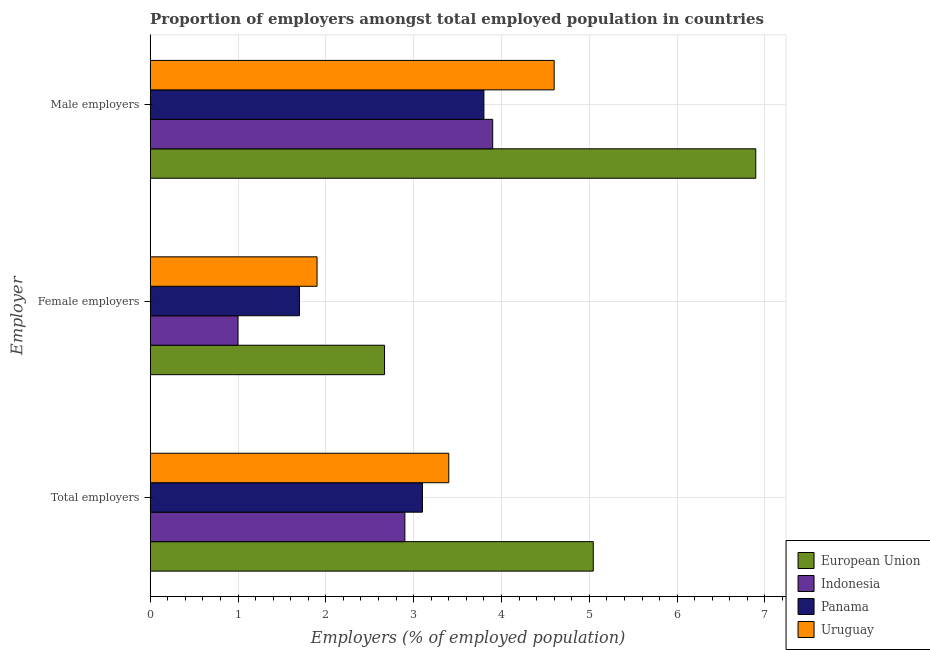How many different coloured bars are there?
Your answer should be compact. 4. Are the number of bars per tick equal to the number of legend labels?
Make the answer very short. Yes. Are the number of bars on each tick of the Y-axis equal?
Offer a very short reply. Yes. How many bars are there on the 2nd tick from the bottom?
Provide a short and direct response. 4. What is the label of the 2nd group of bars from the top?
Offer a very short reply. Female employers. What is the percentage of male employers in Uruguay?
Give a very brief answer. 4.6. Across all countries, what is the maximum percentage of total employers?
Offer a terse response. 5.05. Across all countries, what is the minimum percentage of total employers?
Provide a succinct answer. 2.9. In which country was the percentage of male employers minimum?
Your response must be concise. Panama. What is the total percentage of female employers in the graph?
Keep it short and to the point. 7.27. What is the difference between the percentage of male employers in Panama and that in Indonesia?
Give a very brief answer. -0.1. What is the difference between the percentage of female employers in Uruguay and the percentage of total employers in European Union?
Ensure brevity in your answer.  -3.15. What is the average percentage of female employers per country?
Your answer should be compact. 1.82. What is the difference between the percentage of female employers and percentage of male employers in European Union?
Your answer should be very brief. -4.23. In how many countries, is the percentage of female employers greater than 3.6 %?
Keep it short and to the point. 0. What is the ratio of the percentage of total employers in Panama to that in Indonesia?
Your answer should be very brief. 1.07. Is the percentage of male employers in Indonesia less than that in Uruguay?
Provide a short and direct response. Yes. What is the difference between the highest and the second highest percentage of male employers?
Offer a very short reply. 2.3. What is the difference between the highest and the lowest percentage of male employers?
Make the answer very short. 3.1. Is the sum of the percentage of total employers in Indonesia and European Union greater than the maximum percentage of male employers across all countries?
Provide a short and direct response. Yes. What does the 1st bar from the top in Male employers represents?
Make the answer very short. Uruguay. What does the 4th bar from the bottom in Male employers represents?
Your answer should be compact. Uruguay. How many countries are there in the graph?
Keep it short and to the point. 4. Does the graph contain any zero values?
Give a very brief answer. No. Does the graph contain grids?
Your answer should be compact. Yes. Where does the legend appear in the graph?
Your answer should be compact. Bottom right. How are the legend labels stacked?
Give a very brief answer. Vertical. What is the title of the graph?
Your response must be concise. Proportion of employers amongst total employed population in countries. Does "Papua New Guinea" appear as one of the legend labels in the graph?
Offer a terse response. No. What is the label or title of the X-axis?
Your answer should be very brief. Employers (% of employed population). What is the label or title of the Y-axis?
Give a very brief answer. Employer. What is the Employers (% of employed population) of European Union in Total employers?
Give a very brief answer. 5.05. What is the Employers (% of employed population) of Indonesia in Total employers?
Offer a very short reply. 2.9. What is the Employers (% of employed population) of Panama in Total employers?
Give a very brief answer. 3.1. What is the Employers (% of employed population) in Uruguay in Total employers?
Provide a succinct answer. 3.4. What is the Employers (% of employed population) of European Union in Female employers?
Your answer should be compact. 2.67. What is the Employers (% of employed population) of Indonesia in Female employers?
Keep it short and to the point. 1. What is the Employers (% of employed population) in Panama in Female employers?
Your answer should be very brief. 1.7. What is the Employers (% of employed population) in Uruguay in Female employers?
Keep it short and to the point. 1.9. What is the Employers (% of employed population) of European Union in Male employers?
Provide a short and direct response. 6.9. What is the Employers (% of employed population) of Indonesia in Male employers?
Your response must be concise. 3.9. What is the Employers (% of employed population) of Panama in Male employers?
Your response must be concise. 3.8. What is the Employers (% of employed population) of Uruguay in Male employers?
Ensure brevity in your answer.  4.6. Across all Employer, what is the maximum Employers (% of employed population) of European Union?
Provide a succinct answer. 6.9. Across all Employer, what is the maximum Employers (% of employed population) of Indonesia?
Keep it short and to the point. 3.9. Across all Employer, what is the maximum Employers (% of employed population) in Panama?
Offer a very short reply. 3.8. Across all Employer, what is the maximum Employers (% of employed population) in Uruguay?
Provide a short and direct response. 4.6. Across all Employer, what is the minimum Employers (% of employed population) in European Union?
Keep it short and to the point. 2.67. Across all Employer, what is the minimum Employers (% of employed population) of Panama?
Offer a terse response. 1.7. Across all Employer, what is the minimum Employers (% of employed population) in Uruguay?
Your response must be concise. 1.9. What is the total Employers (% of employed population) in European Union in the graph?
Give a very brief answer. 14.61. What is the total Employers (% of employed population) in Indonesia in the graph?
Give a very brief answer. 7.8. What is the total Employers (% of employed population) in Panama in the graph?
Your answer should be compact. 8.6. What is the difference between the Employers (% of employed population) of European Union in Total employers and that in Female employers?
Offer a very short reply. 2.38. What is the difference between the Employers (% of employed population) in Indonesia in Total employers and that in Female employers?
Your response must be concise. 1.9. What is the difference between the Employers (% of employed population) of European Union in Total employers and that in Male employers?
Offer a terse response. -1.85. What is the difference between the Employers (% of employed population) in Uruguay in Total employers and that in Male employers?
Keep it short and to the point. -1.2. What is the difference between the Employers (% of employed population) of European Union in Female employers and that in Male employers?
Provide a short and direct response. -4.23. What is the difference between the Employers (% of employed population) in Indonesia in Female employers and that in Male employers?
Keep it short and to the point. -2.9. What is the difference between the Employers (% of employed population) in European Union in Total employers and the Employers (% of employed population) in Indonesia in Female employers?
Provide a succinct answer. 4.05. What is the difference between the Employers (% of employed population) of European Union in Total employers and the Employers (% of employed population) of Panama in Female employers?
Give a very brief answer. 3.35. What is the difference between the Employers (% of employed population) in European Union in Total employers and the Employers (% of employed population) in Uruguay in Female employers?
Offer a terse response. 3.15. What is the difference between the Employers (% of employed population) in Indonesia in Total employers and the Employers (% of employed population) in Uruguay in Female employers?
Your response must be concise. 1. What is the difference between the Employers (% of employed population) in Panama in Total employers and the Employers (% of employed population) in Uruguay in Female employers?
Keep it short and to the point. 1.2. What is the difference between the Employers (% of employed population) of European Union in Total employers and the Employers (% of employed population) of Indonesia in Male employers?
Offer a terse response. 1.15. What is the difference between the Employers (% of employed population) in European Union in Total employers and the Employers (% of employed population) in Panama in Male employers?
Your answer should be compact. 1.25. What is the difference between the Employers (% of employed population) in European Union in Total employers and the Employers (% of employed population) in Uruguay in Male employers?
Offer a very short reply. 0.45. What is the difference between the Employers (% of employed population) in Indonesia in Total employers and the Employers (% of employed population) in Panama in Male employers?
Offer a terse response. -0.9. What is the difference between the Employers (% of employed population) in Indonesia in Total employers and the Employers (% of employed population) in Uruguay in Male employers?
Your response must be concise. -1.7. What is the difference between the Employers (% of employed population) of European Union in Female employers and the Employers (% of employed population) of Indonesia in Male employers?
Make the answer very short. -1.23. What is the difference between the Employers (% of employed population) of European Union in Female employers and the Employers (% of employed population) of Panama in Male employers?
Offer a very short reply. -1.13. What is the difference between the Employers (% of employed population) in European Union in Female employers and the Employers (% of employed population) in Uruguay in Male employers?
Provide a succinct answer. -1.93. What is the difference between the Employers (% of employed population) in Indonesia in Female employers and the Employers (% of employed population) in Uruguay in Male employers?
Keep it short and to the point. -3.6. What is the difference between the Employers (% of employed population) of Panama in Female employers and the Employers (% of employed population) of Uruguay in Male employers?
Make the answer very short. -2.9. What is the average Employers (% of employed population) of European Union per Employer?
Offer a terse response. 4.87. What is the average Employers (% of employed population) in Panama per Employer?
Give a very brief answer. 2.87. What is the difference between the Employers (% of employed population) of European Union and Employers (% of employed population) of Indonesia in Total employers?
Ensure brevity in your answer.  2.15. What is the difference between the Employers (% of employed population) of European Union and Employers (% of employed population) of Panama in Total employers?
Your answer should be very brief. 1.95. What is the difference between the Employers (% of employed population) in European Union and Employers (% of employed population) in Uruguay in Total employers?
Make the answer very short. 1.65. What is the difference between the Employers (% of employed population) in Panama and Employers (% of employed population) in Uruguay in Total employers?
Keep it short and to the point. -0.3. What is the difference between the Employers (% of employed population) in European Union and Employers (% of employed population) in Indonesia in Female employers?
Your response must be concise. 1.67. What is the difference between the Employers (% of employed population) in European Union and Employers (% of employed population) in Panama in Female employers?
Give a very brief answer. 0.97. What is the difference between the Employers (% of employed population) of European Union and Employers (% of employed population) of Uruguay in Female employers?
Keep it short and to the point. 0.77. What is the difference between the Employers (% of employed population) in Indonesia and Employers (% of employed population) in Panama in Female employers?
Offer a very short reply. -0.7. What is the difference between the Employers (% of employed population) in Indonesia and Employers (% of employed population) in Uruguay in Female employers?
Offer a terse response. -0.9. What is the difference between the Employers (% of employed population) in European Union and Employers (% of employed population) in Indonesia in Male employers?
Provide a short and direct response. 3. What is the difference between the Employers (% of employed population) of European Union and Employers (% of employed population) of Panama in Male employers?
Provide a succinct answer. 3.1. What is the difference between the Employers (% of employed population) of European Union and Employers (% of employed population) of Uruguay in Male employers?
Ensure brevity in your answer.  2.3. What is the difference between the Employers (% of employed population) in Indonesia and Employers (% of employed population) in Panama in Male employers?
Provide a succinct answer. 0.1. What is the difference between the Employers (% of employed population) of Panama and Employers (% of employed population) of Uruguay in Male employers?
Offer a terse response. -0.8. What is the ratio of the Employers (% of employed population) of European Union in Total employers to that in Female employers?
Make the answer very short. 1.89. What is the ratio of the Employers (% of employed population) in Indonesia in Total employers to that in Female employers?
Ensure brevity in your answer.  2.9. What is the ratio of the Employers (% of employed population) in Panama in Total employers to that in Female employers?
Ensure brevity in your answer.  1.82. What is the ratio of the Employers (% of employed population) in Uruguay in Total employers to that in Female employers?
Make the answer very short. 1.79. What is the ratio of the Employers (% of employed population) in European Union in Total employers to that in Male employers?
Offer a terse response. 0.73. What is the ratio of the Employers (% of employed population) in Indonesia in Total employers to that in Male employers?
Your answer should be very brief. 0.74. What is the ratio of the Employers (% of employed population) of Panama in Total employers to that in Male employers?
Your response must be concise. 0.82. What is the ratio of the Employers (% of employed population) of Uruguay in Total employers to that in Male employers?
Your answer should be compact. 0.74. What is the ratio of the Employers (% of employed population) of European Union in Female employers to that in Male employers?
Ensure brevity in your answer.  0.39. What is the ratio of the Employers (% of employed population) of Indonesia in Female employers to that in Male employers?
Provide a succinct answer. 0.26. What is the ratio of the Employers (% of employed population) in Panama in Female employers to that in Male employers?
Provide a succinct answer. 0.45. What is the ratio of the Employers (% of employed population) of Uruguay in Female employers to that in Male employers?
Offer a very short reply. 0.41. What is the difference between the highest and the second highest Employers (% of employed population) in European Union?
Make the answer very short. 1.85. What is the difference between the highest and the second highest Employers (% of employed population) of Panama?
Keep it short and to the point. 0.7. What is the difference between the highest and the second highest Employers (% of employed population) of Uruguay?
Your answer should be compact. 1.2. What is the difference between the highest and the lowest Employers (% of employed population) in European Union?
Ensure brevity in your answer.  4.23. What is the difference between the highest and the lowest Employers (% of employed population) in Indonesia?
Give a very brief answer. 2.9. What is the difference between the highest and the lowest Employers (% of employed population) of Uruguay?
Your answer should be very brief. 2.7. 